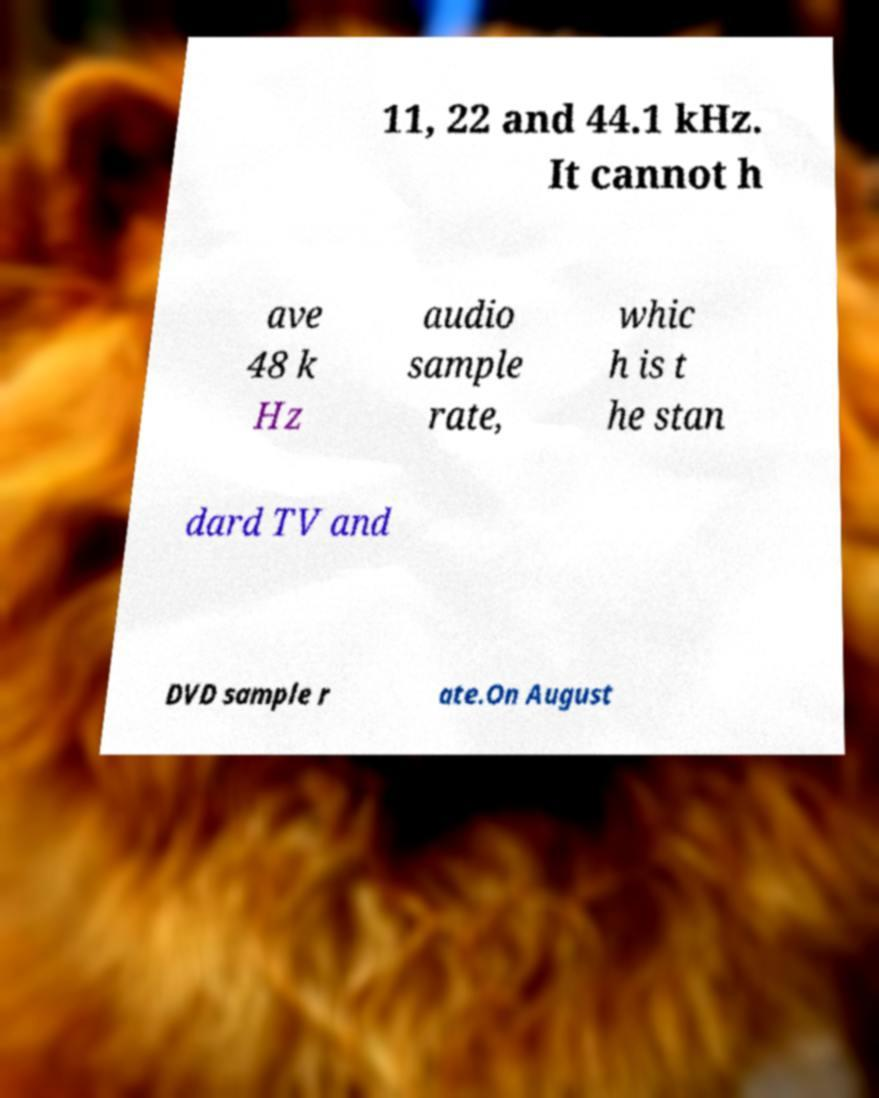I need the written content from this picture converted into text. Can you do that? 11, 22 and 44.1 kHz. It cannot h ave 48 k Hz audio sample rate, whic h is t he stan dard TV and DVD sample r ate.On August 